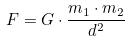Convert formula to latex. <formula><loc_0><loc_0><loc_500><loc_500>F = G \cdot \frac { m _ { 1 } \cdot m _ { 2 } } { d ^ { 2 } }</formula> 